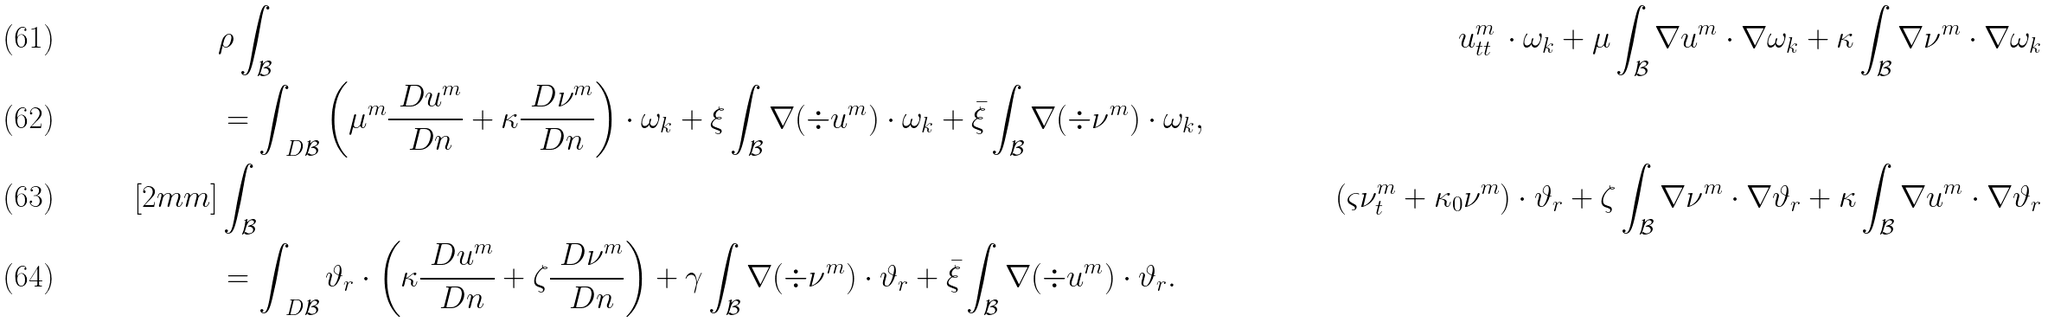Convert formula to latex. <formula><loc_0><loc_0><loc_500><loc_500>& \rho \int _ { \mathcal { B } } & u ^ { m } _ { t t } \, \cdot \omega _ { k } + \mu \int _ { \mathcal { B } } \nabla u ^ { m } \cdot \nabla \omega _ { k } + \kappa \int _ { \mathcal { B } } \nabla \nu ^ { m } \cdot \nabla \omega _ { k } \\ & = \int _ { \ D \mathcal { B } } \left ( \mu ^ { m } \frac { \ D u ^ { m } } { \ D n } + \kappa \frac { \ D \nu ^ { m } } { \ D n } \right ) \cdot \omega _ { k } + \xi \int _ { \mathcal { B } } \nabla ( \div u ^ { m } ) \cdot \omega _ { k } + \bar { \xi } \int _ { \mathcal { B } } \nabla ( \div \nu ^ { m } ) \cdot \omega _ { k } , \\ [ 2 m m ] & \int _ { \mathcal { B } } & ( \varsigma \nu ^ { m } _ { t } + \kappa _ { 0 } \nu ^ { m } ) \cdot \vartheta _ { r } + \zeta \int _ { \mathcal { B } } \nabla \nu ^ { m } \cdot \nabla \vartheta _ { r } + \kappa \int _ { \mathcal { B } } \nabla u ^ { m } \cdot \nabla \vartheta _ { r } \\ & = \int _ { \ D \mathcal { B } } \vartheta _ { r } \cdot \left ( \kappa \frac { \ D u ^ { m } } { \ D n } + \zeta \frac { \ D \nu ^ { m } } { \ D n } \right ) + \gamma \int _ { \mathcal { B } } \nabla ( \div \nu ^ { m } ) \cdot \vartheta _ { r } + \bar { \xi } \int _ { \mathcal { B } } \nabla ( \div u ^ { m } ) \cdot \vartheta _ { r } .</formula> 